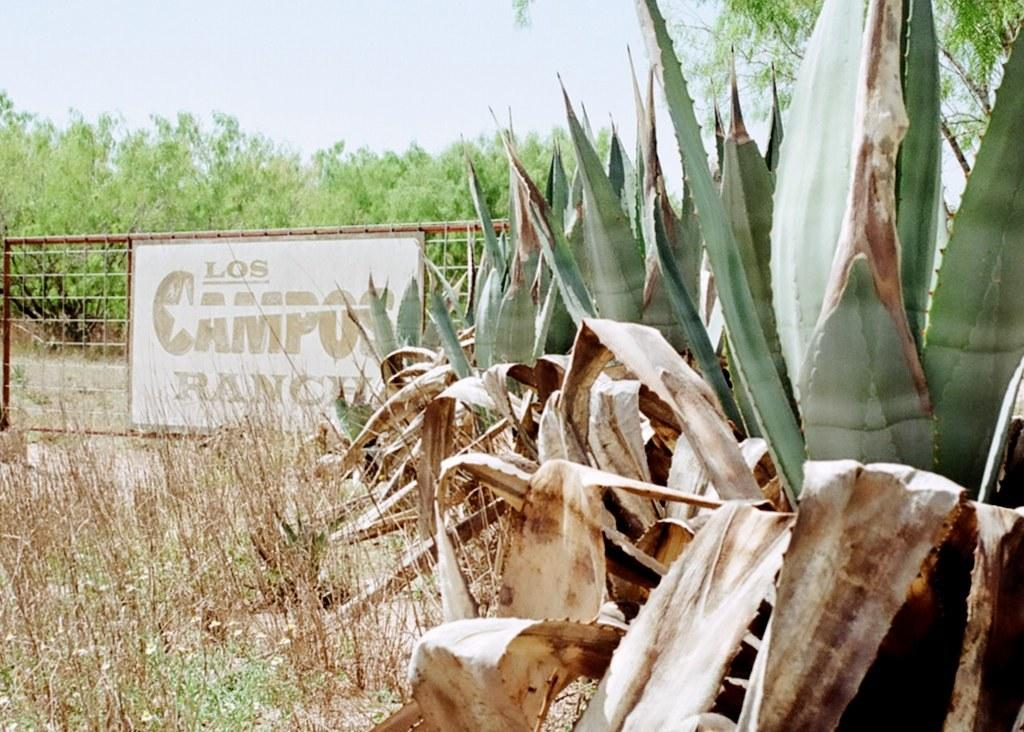What type of vegetation is in the foreground of the image? There are plants in the foreground of the image. What type of ground cover is visible at the bottom of the image? There is grass at the bottom of the image. What object is located in the center of the image? There is a board in the center of the image. What type of tall vegetation is present in the image? There are trees in the image. What is visible at the top of the image? The sky is visible at the top of the image. What type of pest can be seen crawling on the board in the image? There are no pests visible in the image; the board is clear of any such creatures. What type of street is visible in the image? There is no street present in the image; it features plants, grass, a board, trees, and the sky. 